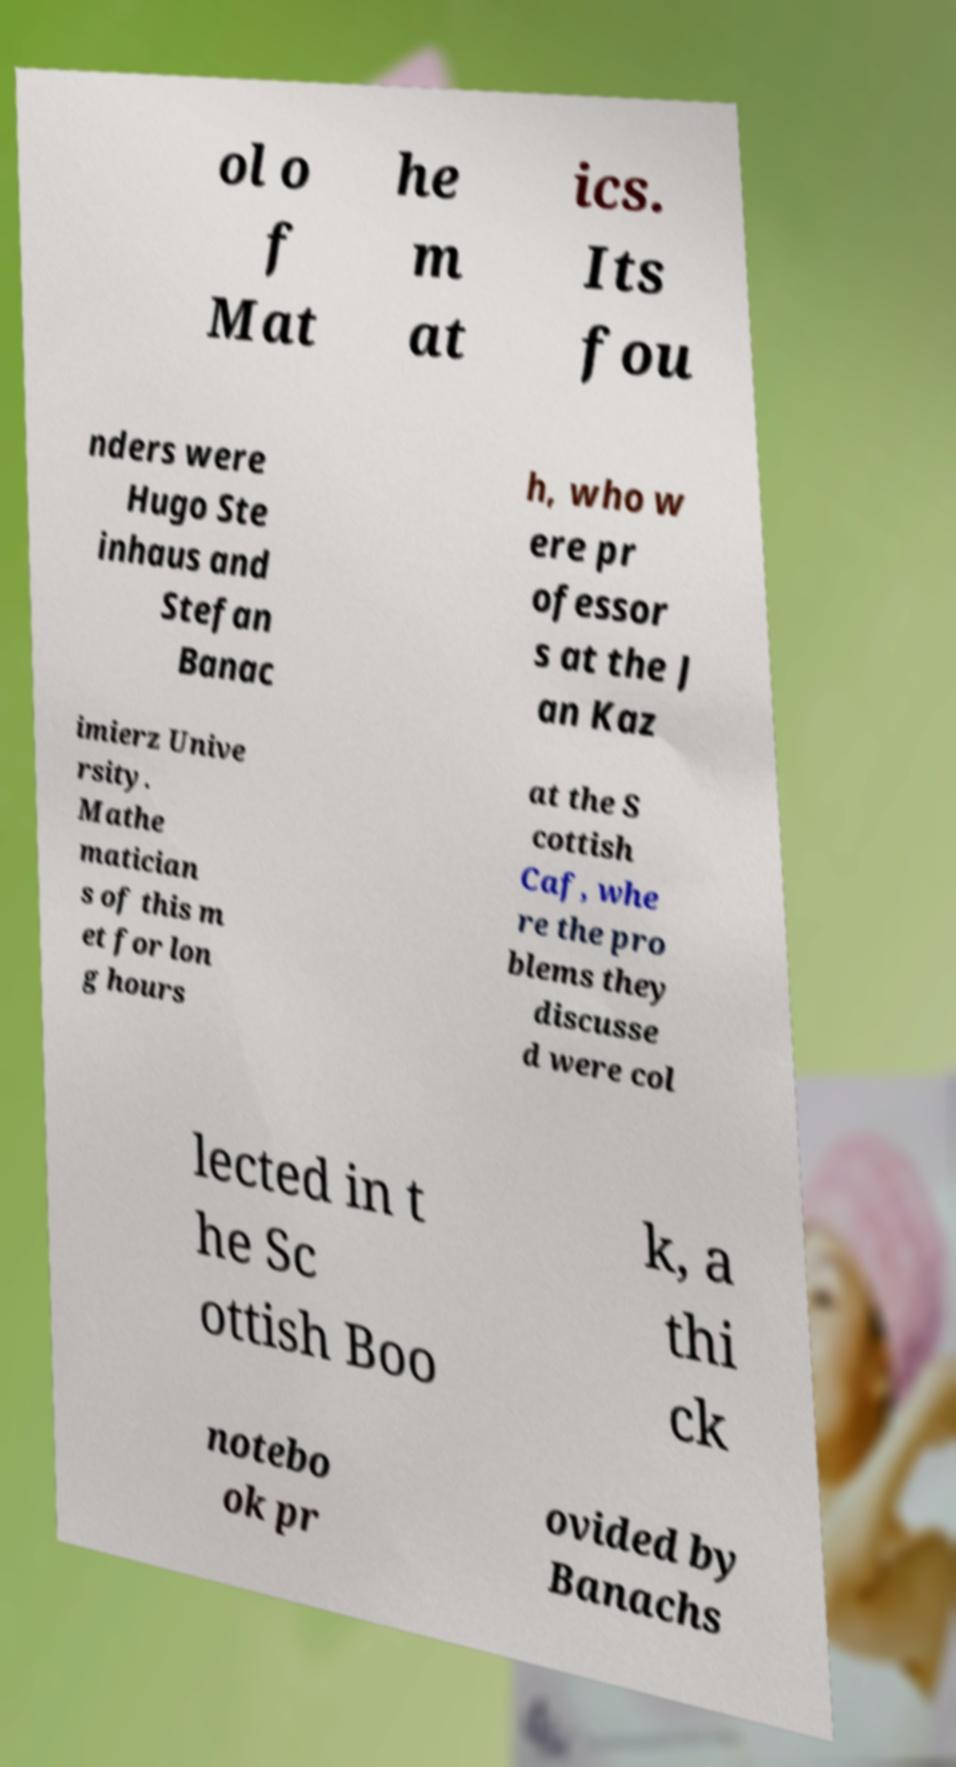There's text embedded in this image that I need extracted. Can you transcribe it verbatim? ol o f Mat he m at ics. Its fou nders were Hugo Ste inhaus and Stefan Banac h, who w ere pr ofessor s at the J an Kaz imierz Unive rsity. Mathe matician s of this m et for lon g hours at the S cottish Caf, whe re the pro blems they discusse d were col lected in t he Sc ottish Boo k, a thi ck notebo ok pr ovided by Banachs 